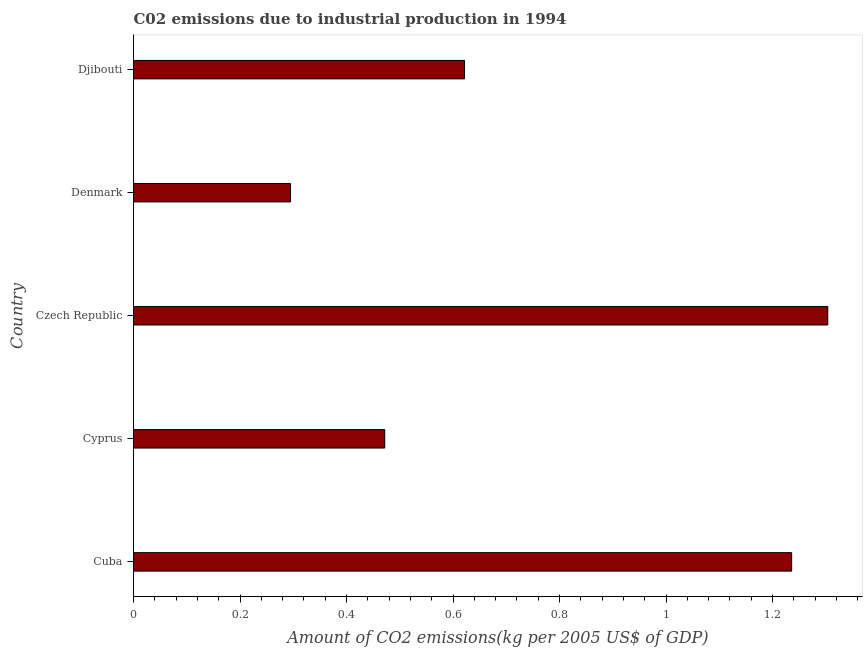Does the graph contain grids?
Your answer should be very brief. No. What is the title of the graph?
Offer a terse response. C02 emissions due to industrial production in 1994. What is the label or title of the X-axis?
Make the answer very short. Amount of CO2 emissions(kg per 2005 US$ of GDP). What is the label or title of the Y-axis?
Make the answer very short. Country. What is the amount of co2 emissions in Czech Republic?
Your answer should be compact. 1.3. Across all countries, what is the maximum amount of co2 emissions?
Offer a very short reply. 1.3. Across all countries, what is the minimum amount of co2 emissions?
Offer a very short reply. 0.29. In which country was the amount of co2 emissions maximum?
Make the answer very short. Czech Republic. In which country was the amount of co2 emissions minimum?
Provide a succinct answer. Denmark. What is the sum of the amount of co2 emissions?
Provide a succinct answer. 3.93. What is the difference between the amount of co2 emissions in Cuba and Djibouti?
Keep it short and to the point. 0.61. What is the average amount of co2 emissions per country?
Keep it short and to the point. 0.79. What is the median amount of co2 emissions?
Offer a very short reply. 0.62. In how many countries, is the amount of co2 emissions greater than 0.72 kg per 2005 US$ of GDP?
Give a very brief answer. 2. What is the ratio of the amount of co2 emissions in Czech Republic to that in Djibouti?
Keep it short and to the point. 2.1. Is the amount of co2 emissions in Denmark less than that in Djibouti?
Keep it short and to the point. Yes. Is the difference between the amount of co2 emissions in Cuba and Czech Republic greater than the difference between any two countries?
Keep it short and to the point. No. What is the difference between the highest and the second highest amount of co2 emissions?
Offer a very short reply. 0.07. Is the sum of the amount of co2 emissions in Cuba and Djibouti greater than the maximum amount of co2 emissions across all countries?
Your answer should be compact. Yes. How many bars are there?
Give a very brief answer. 5. Are all the bars in the graph horizontal?
Ensure brevity in your answer.  Yes. What is the Amount of CO2 emissions(kg per 2005 US$ of GDP) of Cuba?
Your answer should be very brief. 1.24. What is the Amount of CO2 emissions(kg per 2005 US$ of GDP) of Cyprus?
Make the answer very short. 0.47. What is the Amount of CO2 emissions(kg per 2005 US$ of GDP) in Czech Republic?
Give a very brief answer. 1.3. What is the Amount of CO2 emissions(kg per 2005 US$ of GDP) of Denmark?
Your response must be concise. 0.29. What is the Amount of CO2 emissions(kg per 2005 US$ of GDP) in Djibouti?
Provide a short and direct response. 0.62. What is the difference between the Amount of CO2 emissions(kg per 2005 US$ of GDP) in Cuba and Cyprus?
Offer a very short reply. 0.76. What is the difference between the Amount of CO2 emissions(kg per 2005 US$ of GDP) in Cuba and Czech Republic?
Provide a short and direct response. -0.07. What is the difference between the Amount of CO2 emissions(kg per 2005 US$ of GDP) in Cuba and Denmark?
Make the answer very short. 0.94. What is the difference between the Amount of CO2 emissions(kg per 2005 US$ of GDP) in Cuba and Djibouti?
Provide a succinct answer. 0.61. What is the difference between the Amount of CO2 emissions(kg per 2005 US$ of GDP) in Cyprus and Czech Republic?
Give a very brief answer. -0.83. What is the difference between the Amount of CO2 emissions(kg per 2005 US$ of GDP) in Cyprus and Denmark?
Make the answer very short. 0.18. What is the difference between the Amount of CO2 emissions(kg per 2005 US$ of GDP) in Cyprus and Djibouti?
Provide a short and direct response. -0.15. What is the difference between the Amount of CO2 emissions(kg per 2005 US$ of GDP) in Czech Republic and Denmark?
Offer a terse response. 1.01. What is the difference between the Amount of CO2 emissions(kg per 2005 US$ of GDP) in Czech Republic and Djibouti?
Make the answer very short. 0.68. What is the difference between the Amount of CO2 emissions(kg per 2005 US$ of GDP) in Denmark and Djibouti?
Your response must be concise. -0.33. What is the ratio of the Amount of CO2 emissions(kg per 2005 US$ of GDP) in Cuba to that in Cyprus?
Provide a succinct answer. 2.62. What is the ratio of the Amount of CO2 emissions(kg per 2005 US$ of GDP) in Cuba to that in Czech Republic?
Your answer should be very brief. 0.95. What is the ratio of the Amount of CO2 emissions(kg per 2005 US$ of GDP) in Cuba to that in Denmark?
Provide a short and direct response. 4.19. What is the ratio of the Amount of CO2 emissions(kg per 2005 US$ of GDP) in Cuba to that in Djibouti?
Give a very brief answer. 1.99. What is the ratio of the Amount of CO2 emissions(kg per 2005 US$ of GDP) in Cyprus to that in Czech Republic?
Ensure brevity in your answer.  0.36. What is the ratio of the Amount of CO2 emissions(kg per 2005 US$ of GDP) in Cyprus to that in Denmark?
Keep it short and to the point. 1.6. What is the ratio of the Amount of CO2 emissions(kg per 2005 US$ of GDP) in Cyprus to that in Djibouti?
Offer a terse response. 0.76. What is the ratio of the Amount of CO2 emissions(kg per 2005 US$ of GDP) in Czech Republic to that in Denmark?
Keep it short and to the point. 4.42. What is the ratio of the Amount of CO2 emissions(kg per 2005 US$ of GDP) in Czech Republic to that in Djibouti?
Provide a succinct answer. 2.1. What is the ratio of the Amount of CO2 emissions(kg per 2005 US$ of GDP) in Denmark to that in Djibouti?
Offer a terse response. 0.47. 